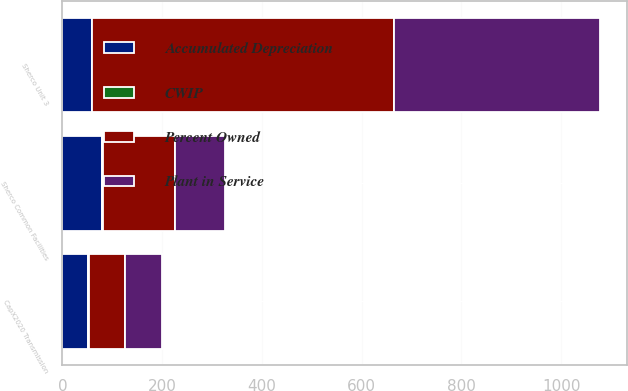Convert chart to OTSL. <chart><loc_0><loc_0><loc_500><loc_500><stacked_bar_chart><ecel><fcel>Sherco Unit 3<fcel>Sherco Common Facilities<fcel>CapX2020 Transmission<nl><fcel>Percent Owned<fcel>604<fcel>145<fcel>73<nl><fcel>Plant in Service<fcel>415<fcel>100<fcel>73<nl><fcel>CWIP<fcel>1<fcel>1<fcel>2<nl><fcel>Accumulated Depreciation<fcel>59<fcel>80<fcel>51<nl></chart> 